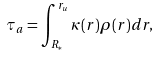<formula> <loc_0><loc_0><loc_500><loc_500>\tau _ { a } = \int _ { R _ { \ast } } ^ { r _ { u } } \kappa ( r ) \rho ( r ) d r ,</formula> 